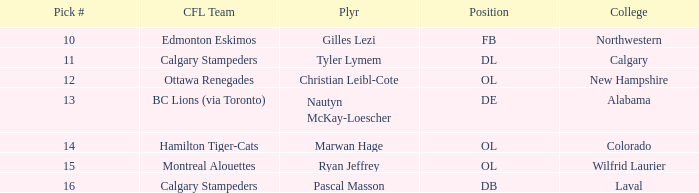What position does Christian Leibl-Cote play? OL. 